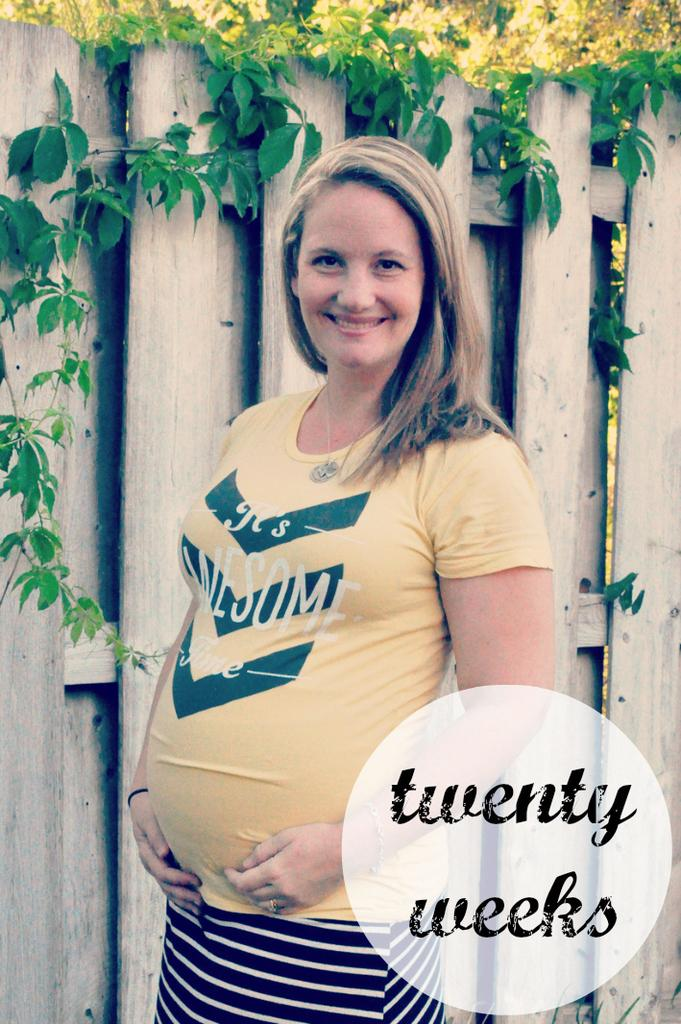Who is in the picture? There is a woman in the picture. What is the woman wearing? The woman is wearing a yellow T-shirt. What expression does the woman have? The woman has a smile on her face. What type of fencing can be seen in the picture? There is wooden fencing in the picture. What type of vegetation is visible at the top of the picture? Green leaves are visible at the top of the picture. What type of oil is being used to water the lettuce in the picture? There is no lettuce or oil present in the image; it features a woman with a smile, wearing a yellow T-shirt, and surrounded by wooden fencing and green leaves. 